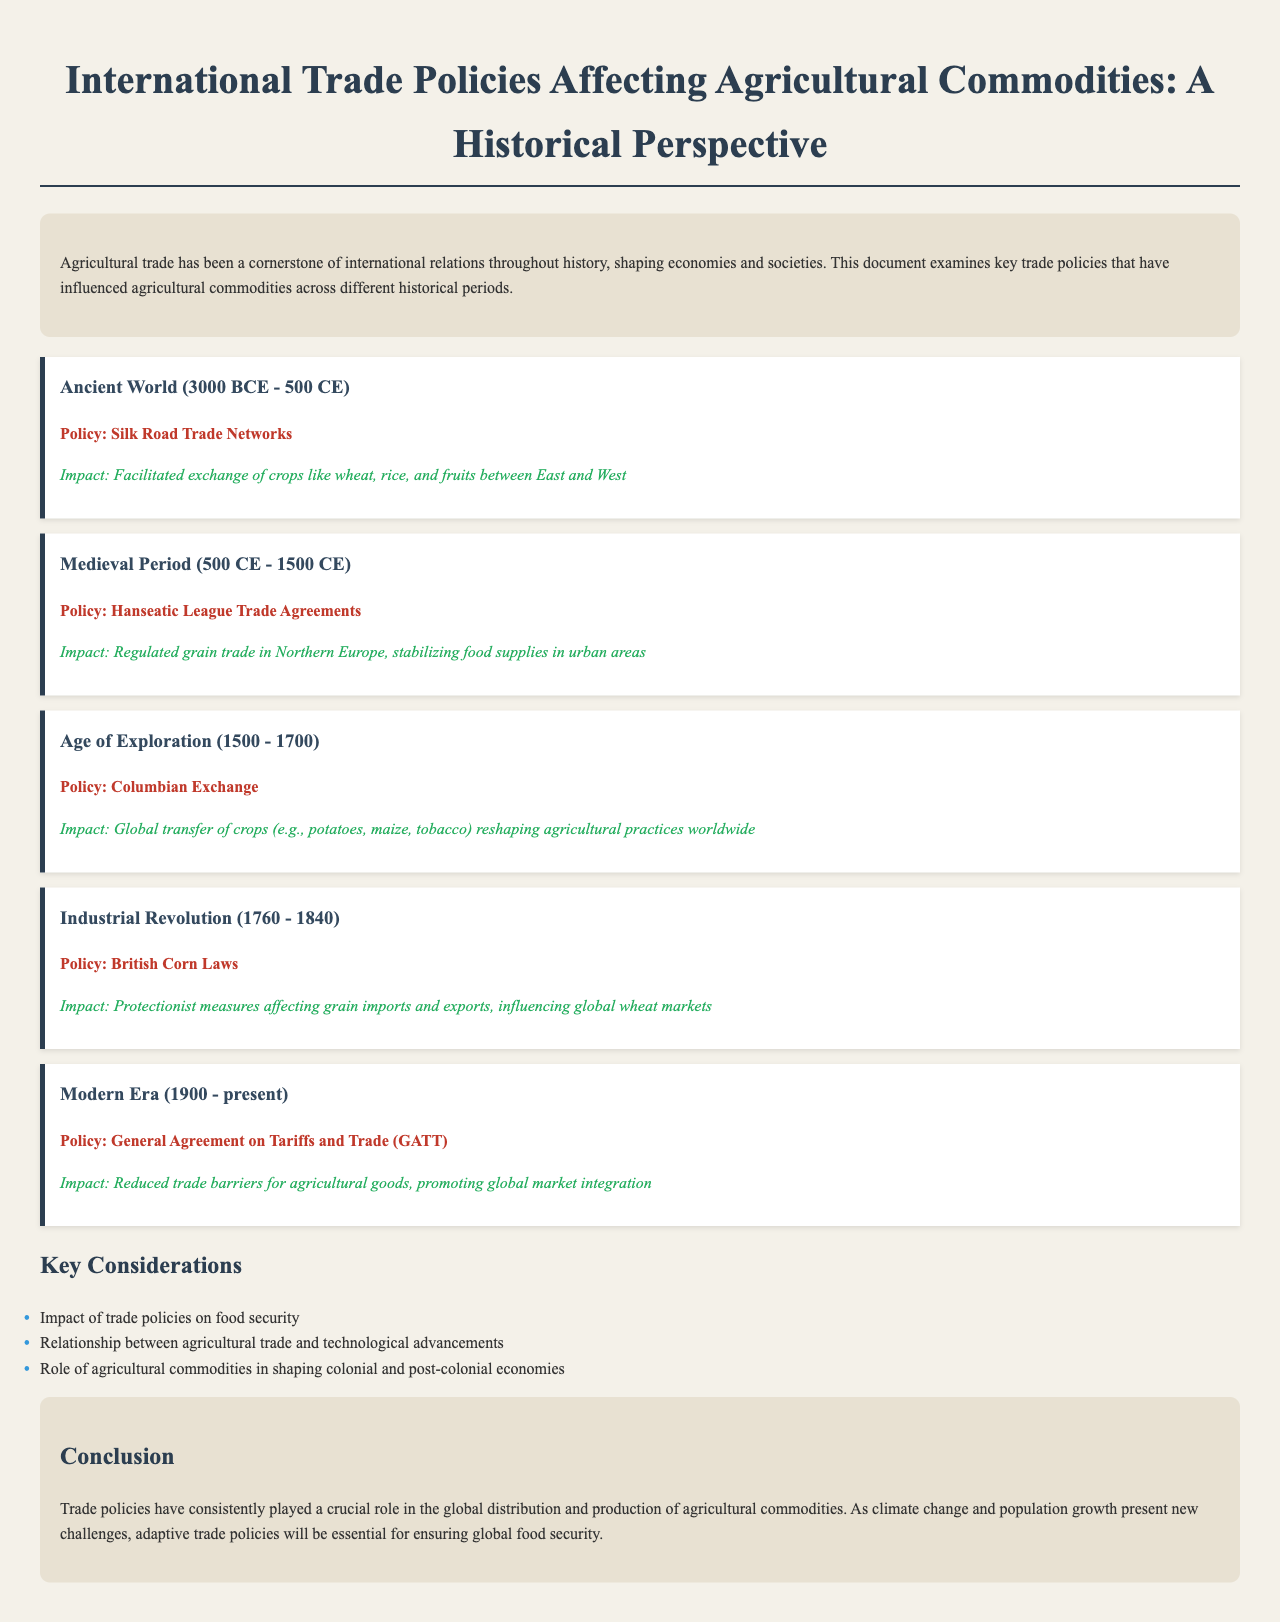What trade network facilitated the exchange of crops in the Ancient World? The document states that the Silk Road Trade Networks facilitated the exchange of crops.
Answer: Silk Road Trade Networks Which trade agreements regulated grain trade in the Medieval Period? The document mentions the Hanseatic League Trade Agreements as regulating grain trade.
Answer: Hanseatic League Trade Agreements During which historical period was the Columbian Exchange significant? The document specifies the Age of Exploration as the period when the Columbian Exchange was significant.
Answer: Age of Exploration What protectionist measures affected grain imports during the Industrial Revolution? The document refers to the British Corn Laws as the protectionist measures during that time.
Answer: British Corn Laws What agreement aimed to reduce trade barriers for agricultural goods in the Modern Era? The document identifies the General Agreement on Tariffs and Trade (GATT) as the agreement aimed at this purpose.
Answer: General Agreement on Tariffs and Trade (GATT) What was one impact of the Columbian Exchange on agricultural practices? The document mentions the global transfer of crops reshaping agricultural practices as an impact.
Answer: Global transfer of crops What is one key consideration regarding agricultural trade policies mentioned in the document? The document lists the impact of trade policies on food security as a key consideration.
Answer: Impact on food security In which year range did the Industrial Revolution occur? The document indicates that the Industrial Revolution occurred from 1760 to 1840.
Answer: 1760 - 1840 What major challenge is highlighted in the conclusion regarding future trade policies? The document states that adaptive trade policies will be essential for ensuring global food security as a major challenge.
Answer: Global food security 